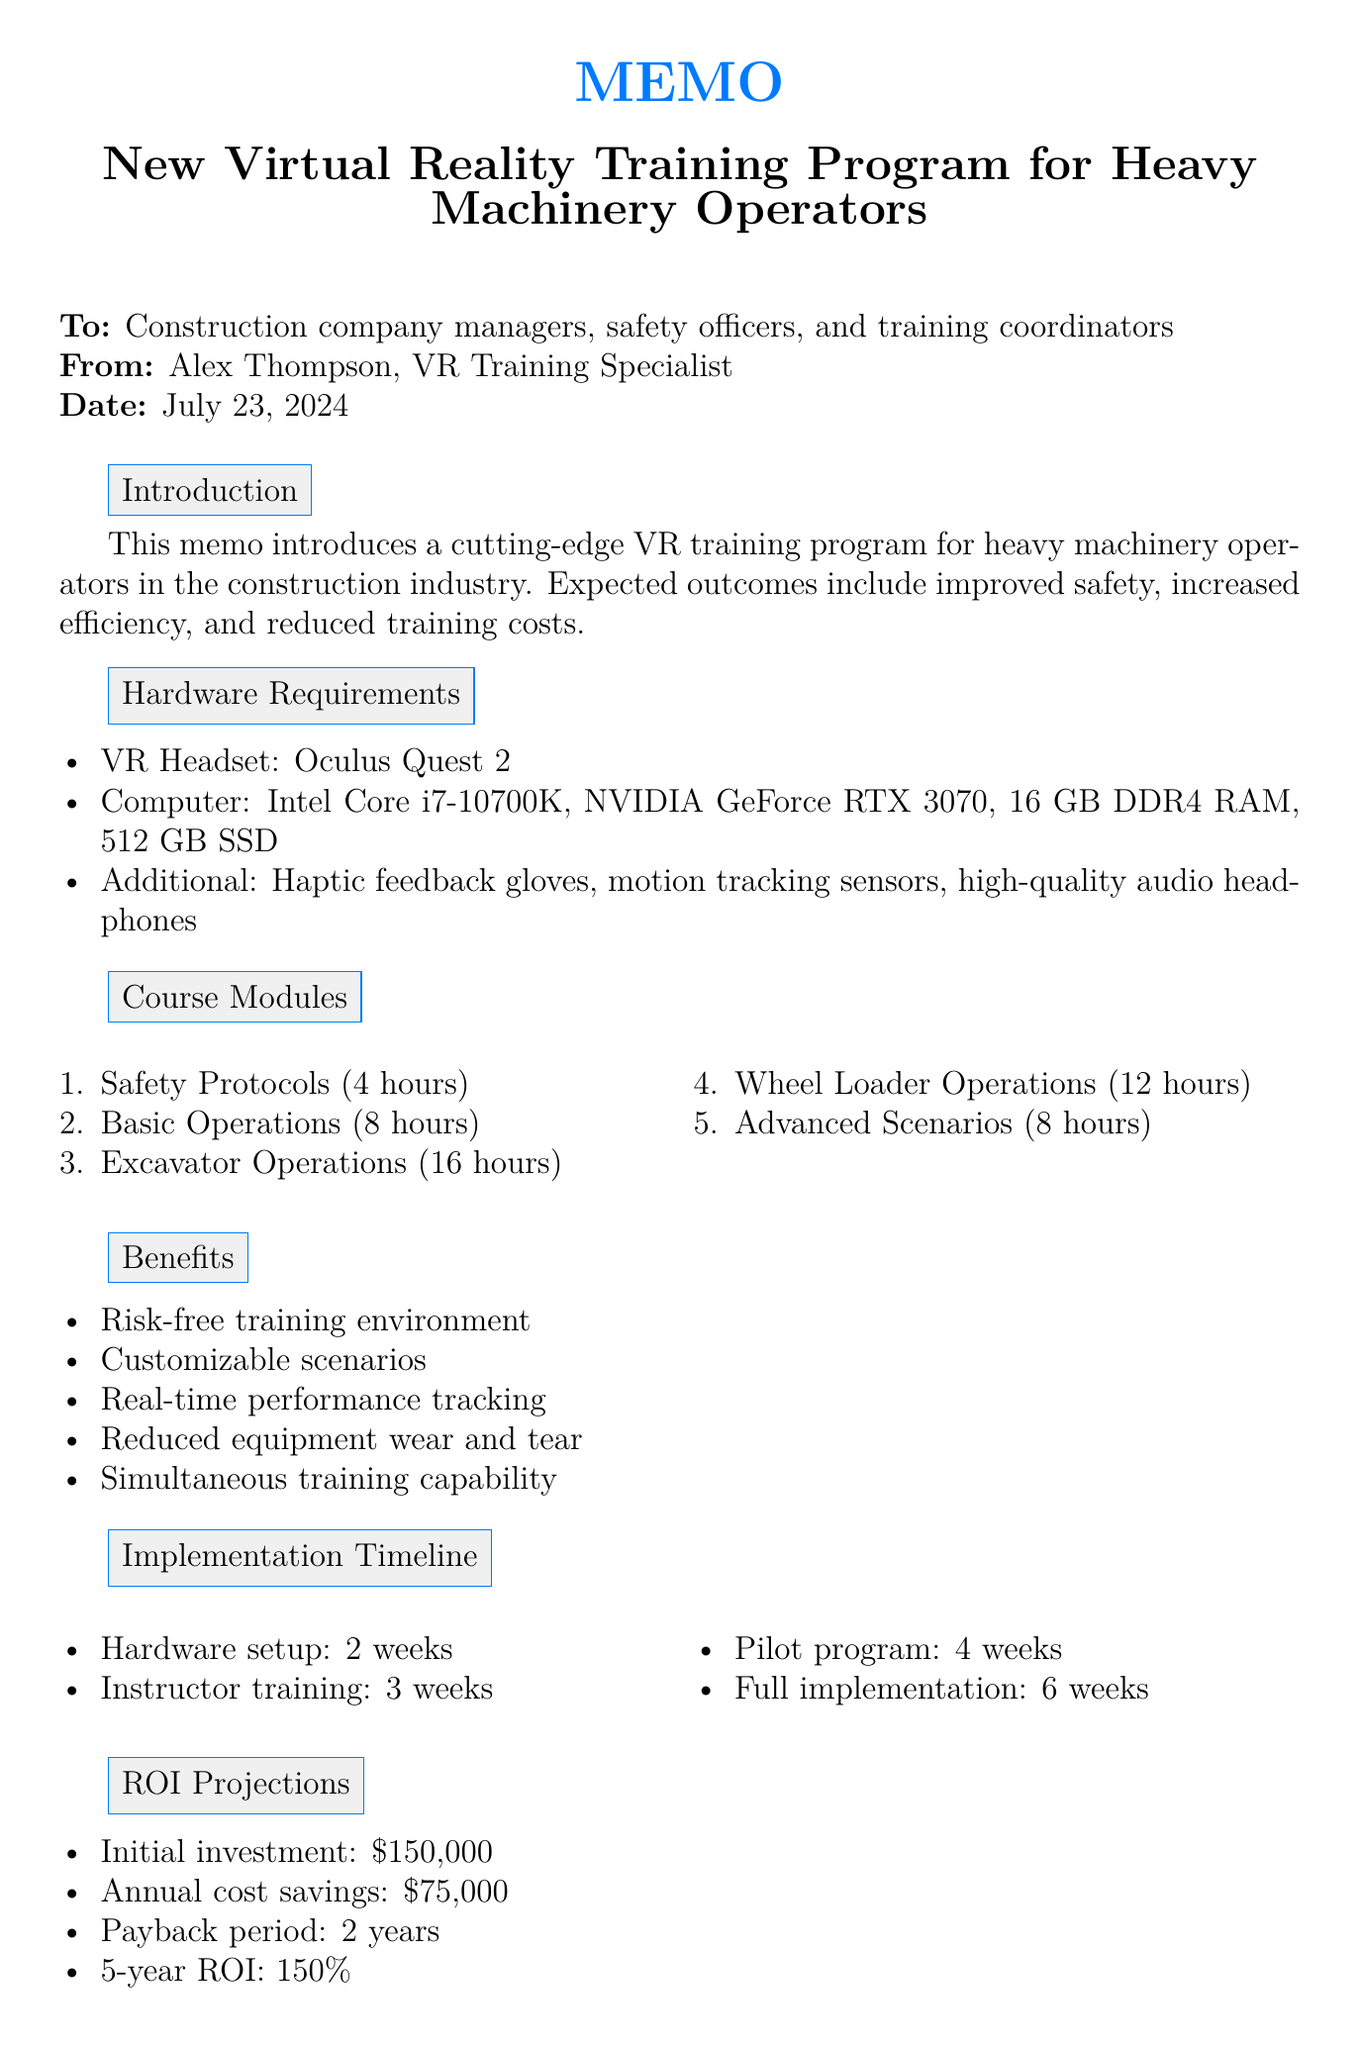What is the title of the memo? The title is provided at the beginning of the document, which is about the new training program for heavy machinery operators.
Answer: New Virtual Reality Training Program for Heavy Machinery Operators Who is the target audience for the training program? The target audience is specified in the introduction section of the memo.
Answer: Construction company managers, safety officers, and training coordinators What is the duration of the "Excavator Operations" module? The duration is listed alongside each course module in the document.
Answer: 16 hours What is the initial investment required for the program? The initial investment is mentioned in the ROI projections section.
Answer: $150,000 How long is the hardware acquisition phase? The implementation timeline section provides the duration for each phase.
Answer: 2 weeks What type of VR headset is specified in the hardware requirements? The hardware requirements section lists the specific headset recommended for the program.
Answer: Oculus Quest 2 What is one of the key benefits of the training program? The benefits of the program are enumerated in the document, highlighting its advantages.
Answer: Risk-free training environment Which module covers emergency procedures? The course modules section details the names of each training module.
Answer: Advanced Scenarios and Emergency Procedures Who should be contacted for more information? The contact information is clearly provided in the conclusion section of the memo.
Answer: Alex Thompson 